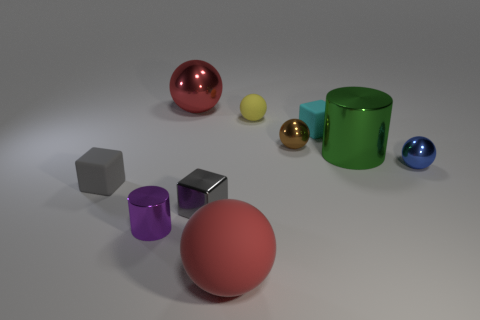Do the big thing that is in front of the blue metal object and the big object that is behind the small brown shiny ball have the same material?
Provide a succinct answer. No. What number of blocks are tiny cyan things or big red things?
Offer a very short reply. 1. There is a cylinder that is left of the large red object behind the blue metal ball; what number of green objects are in front of it?
Give a very brief answer. 0. There is a tiny cyan thing that is the same shape as the gray matte object; what is its material?
Provide a short and direct response. Rubber. Are there any other things that have the same material as the tiny blue sphere?
Offer a terse response. Yes. The tiny sphere that is in front of the green object is what color?
Keep it short and to the point. Blue. Are the cyan object and the small sphere left of the tiny brown thing made of the same material?
Provide a succinct answer. Yes. What material is the purple cylinder?
Provide a succinct answer. Metal. There is a large red thing that is made of the same material as the yellow ball; what is its shape?
Keep it short and to the point. Sphere. What number of other objects are there of the same shape as the large rubber thing?
Make the answer very short. 4. 